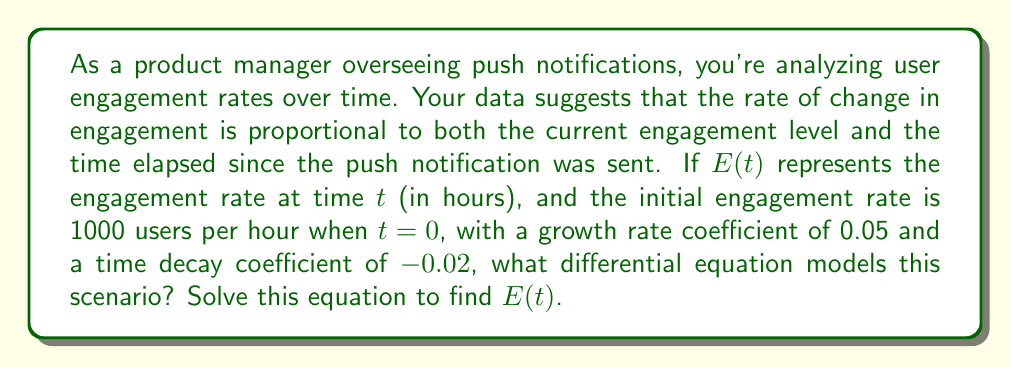Could you help me with this problem? Let's approach this step-by-step:

1) The problem description suggests a second-order linear differential equation. The rate of change in engagement is proportional to both the current engagement and time:

   $$\frac{d^2E}{dt^2} = k_1E + k_2t$$

   where $k_1$ is the growth rate coefficient and $k_2$ is the time decay coefficient.

2) Given the information:
   - $k_1 = 0.05$
   - $k_2 = -0.02$
   - Initial condition: $E(0) = 1000$

3) Our differential equation becomes:

   $$\frac{d^2E}{dt^2} = 0.05E - 0.02t$$

4) To solve this, we need to find the general solution and then apply the initial condition. The general solution for this type of equation is:

   $$E(t) = c_1e^{\sqrt{k_1}t} + c_2e^{-\sqrt{k_1}t} - \frac{k_2}{k_1}t$$

5) Substituting our values:

   $$E(t) = c_1e^{\sqrt{0.05}t} + c_2e^{-\sqrt{0.05}t} + 0.4t$$

6) To find $c_1$ and $c_2$, we need two conditions. We're given $E(0) = 1000$, and we can assume $\frac{dE}{dt}(0) = 0$ (rate of change is initially zero).

7) Applying $E(0) = 1000$:

   $$1000 = c_1 + c_2$$

8) Differentiating $E(t)$ and applying $\frac{dE}{dt}(0) = 0$:

   $$0 = c_1\sqrt{0.05} - c_2\sqrt{0.05} + 0.4$$

9) Solving these simultaneous equations:

   $$c_1 = 500 + \frac{0.4}{\sqrt{0.05}} \approx 501.79$$
   $$c_2 = 500 - \frac{0.4}{\sqrt{0.05}} \approx 498.21$$

10) Therefore, the final solution is:

    $$E(t) = 501.79e^{\sqrt{0.05}t} + 498.21e^{-\sqrt{0.05}t} + 0.4t$$
Answer: The differential equation modeling the scenario is:

$$\frac{d^2E}{dt^2} = 0.05E - 0.02t$$

The solution for $E(t)$ is:

$$E(t) = 501.79e^{\sqrt{0.05}t} + 498.21e^{-\sqrt{0.05}t} + 0.4t$$ 